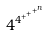<formula> <loc_0><loc_0><loc_500><loc_500>4 ^ { 4 ^ { + ^ { + ^ { + ^ { n } } } } }</formula> 